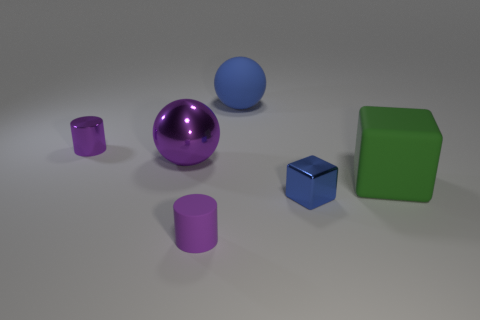Subtract all purple spheres. How many spheres are left? 1 Add 3 matte balls. How many matte balls exist? 4 Add 2 rubber blocks. How many objects exist? 8 Subtract 0 cyan blocks. How many objects are left? 6 Subtract all cubes. How many objects are left? 4 Subtract 1 cylinders. How many cylinders are left? 1 Subtract all red spheres. Subtract all yellow cylinders. How many spheres are left? 2 Subtract all red blocks. How many blue balls are left? 1 Subtract all tiny yellow matte blocks. Subtract all cylinders. How many objects are left? 4 Add 6 purple shiny things. How many purple shiny things are left? 8 